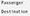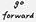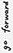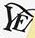Read the text content from these images in order, separated by a semicolon. #; #; #; YE 